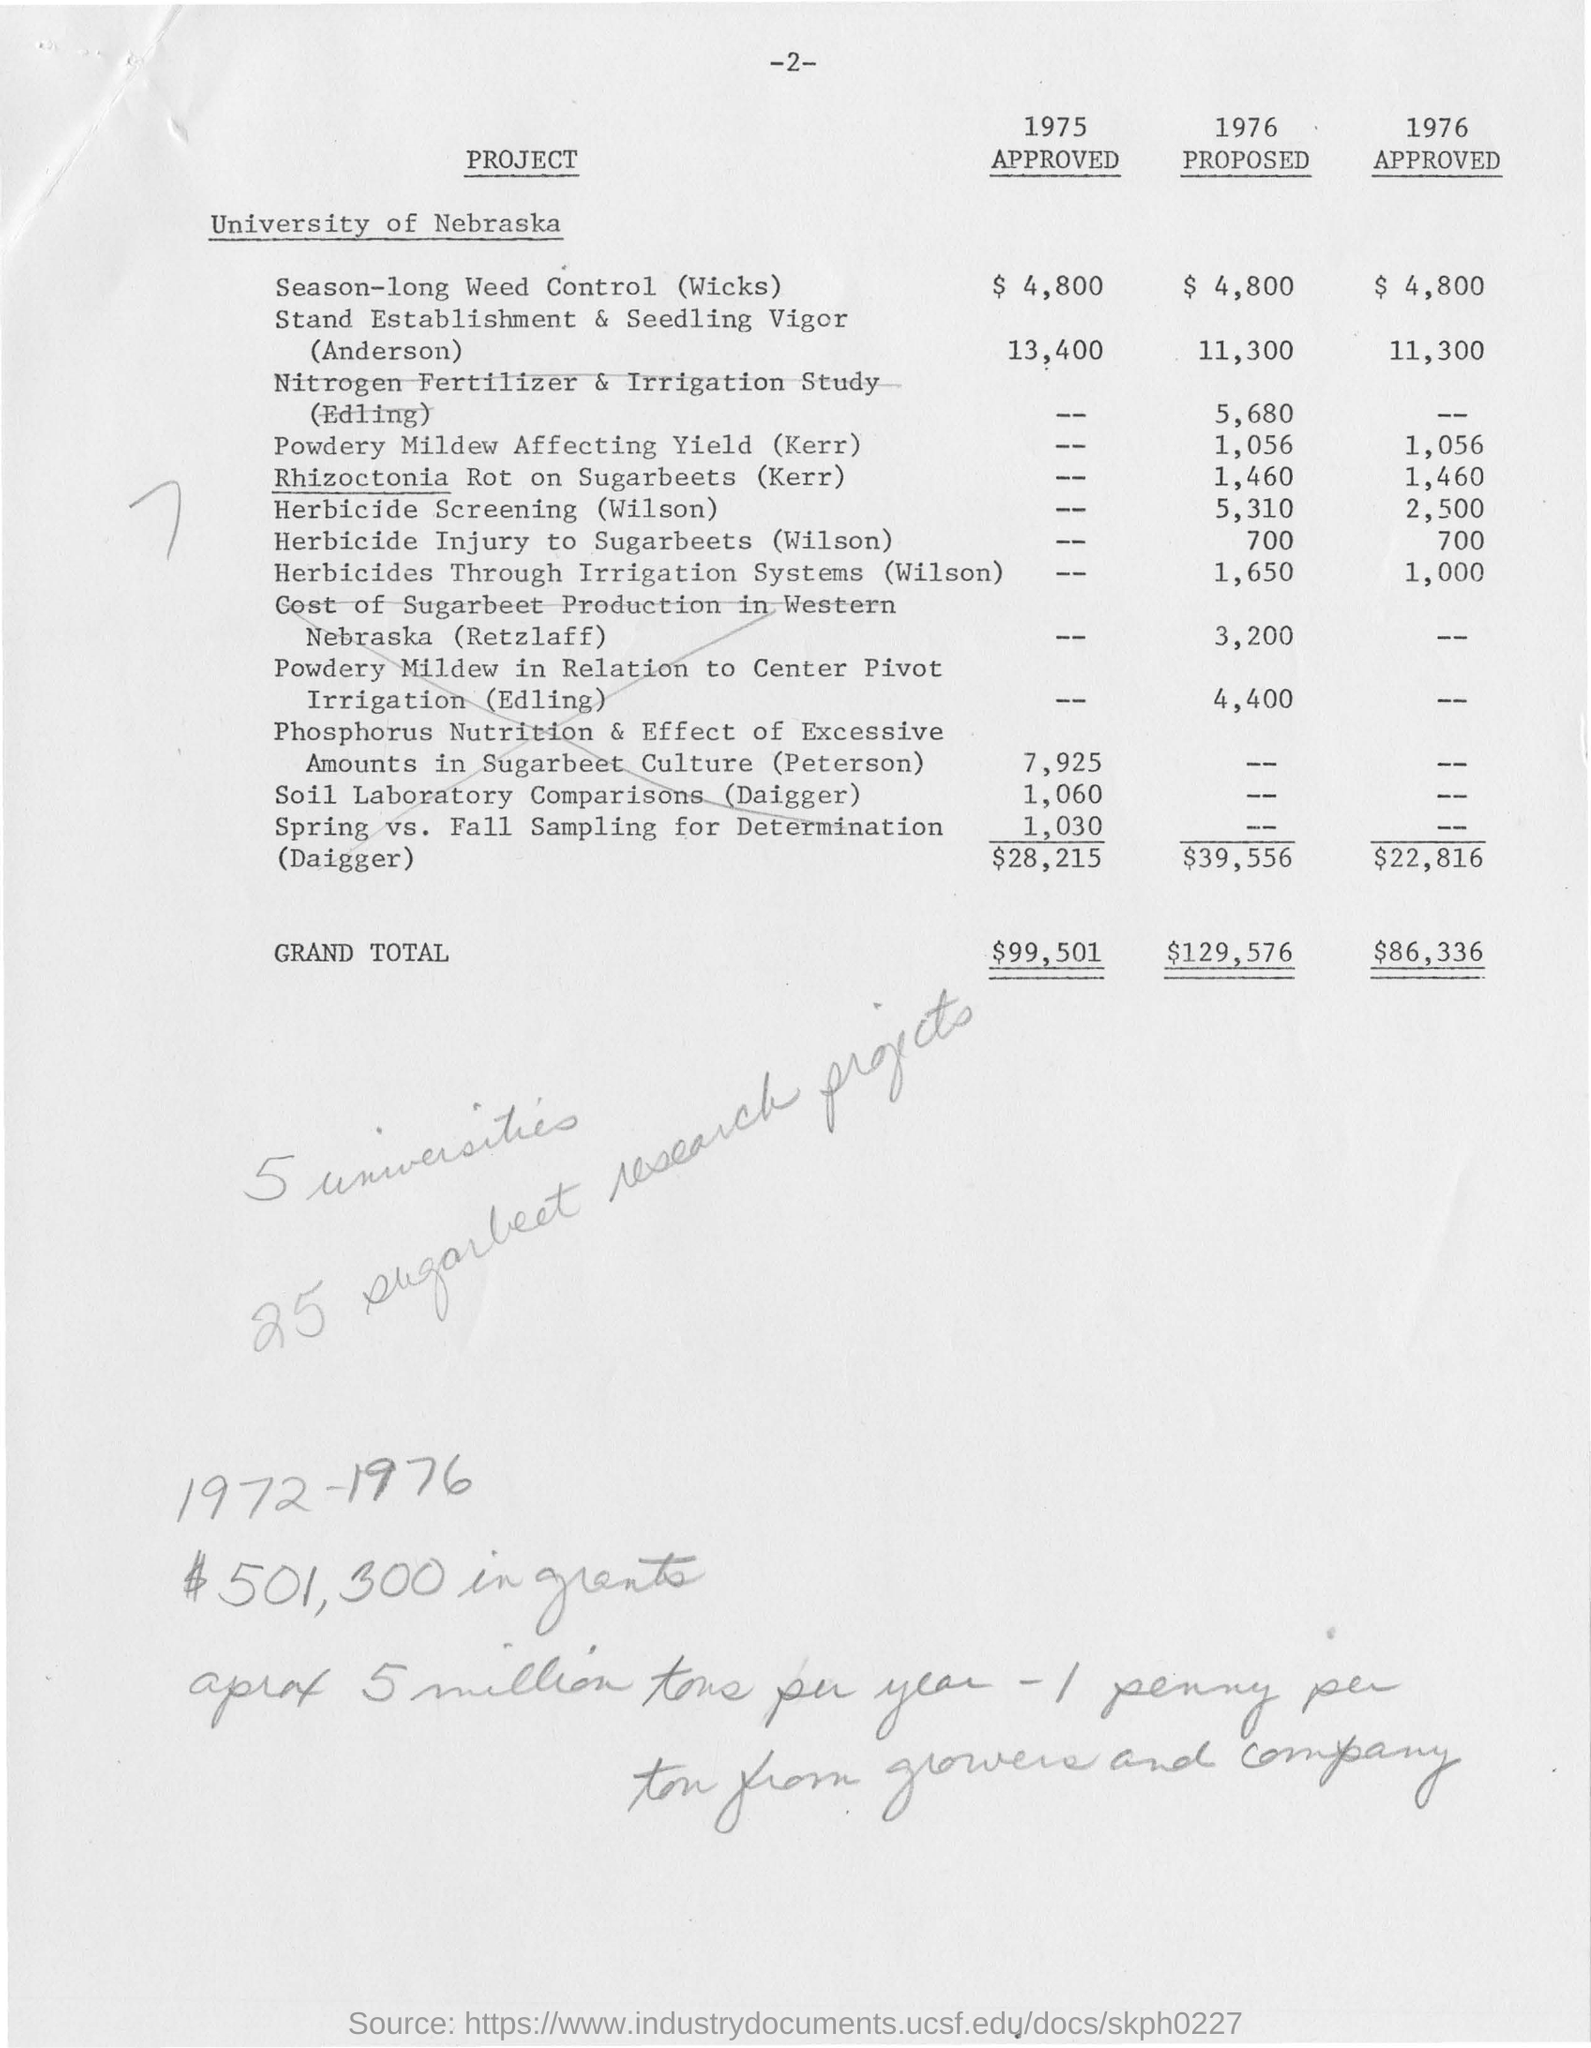What is the name of the university mentioned ?
Provide a short and direct response. University of Nebraska. What is the grand total amount for the year 1975 ?
Provide a short and direct response. $99,501. What is the proposed grand total amount for the year 1976 ?
Offer a very short reply. $ 129,576. What is the approved grand total amount for the year 1976 ?
Your answer should be compact. $ 86,336. What is the approved amount for season-long weed control (wicks) in the year 1975 ?
Make the answer very short. $ 4,800. 